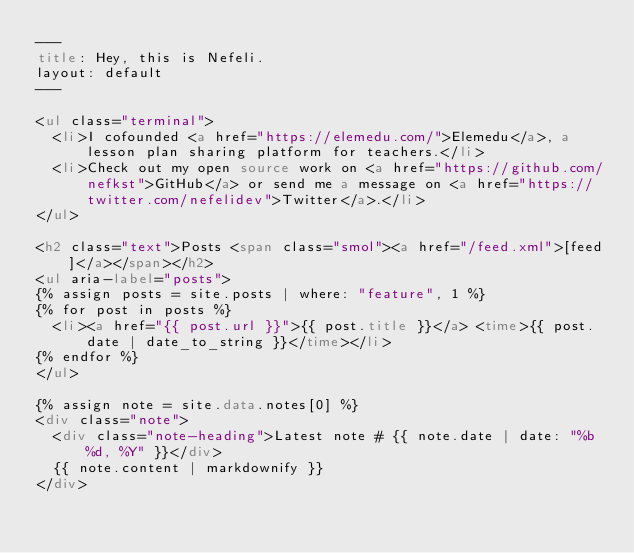Convert code to text. <code><loc_0><loc_0><loc_500><loc_500><_HTML_>---
title: Hey, this is Nefeli.
layout: default
---

<ul class="terminal">
  <li>I cofounded <a href="https://elemedu.com/">Elemedu</a>, a lesson plan sharing platform for teachers.</li>
  <li>Check out my open source work on <a href="https://github.com/nefkst">GitHub</a> or send me a message on <a href="https://twitter.com/nefelidev">Twitter</a>.</li>
</ul>

<h2 class="text">Posts <span class="smol"><a href="/feed.xml">[feed]</a></span></h2>
<ul aria-label="posts">
{% assign posts = site.posts | where: "feature", 1 %}
{% for post in posts %}
  <li><a href="{{ post.url }}">{{ post.title }}</a> <time>{{ post.date | date_to_string }}</time></li>
{% endfor %}
</ul>

{% assign note = site.data.notes[0] %}
<div class="note">
  <div class="note-heading">Latest note # {{ note.date | date: "%b %d, %Y" }}</div>
  {{ note.content | markdownify }}
</div>
</code> 